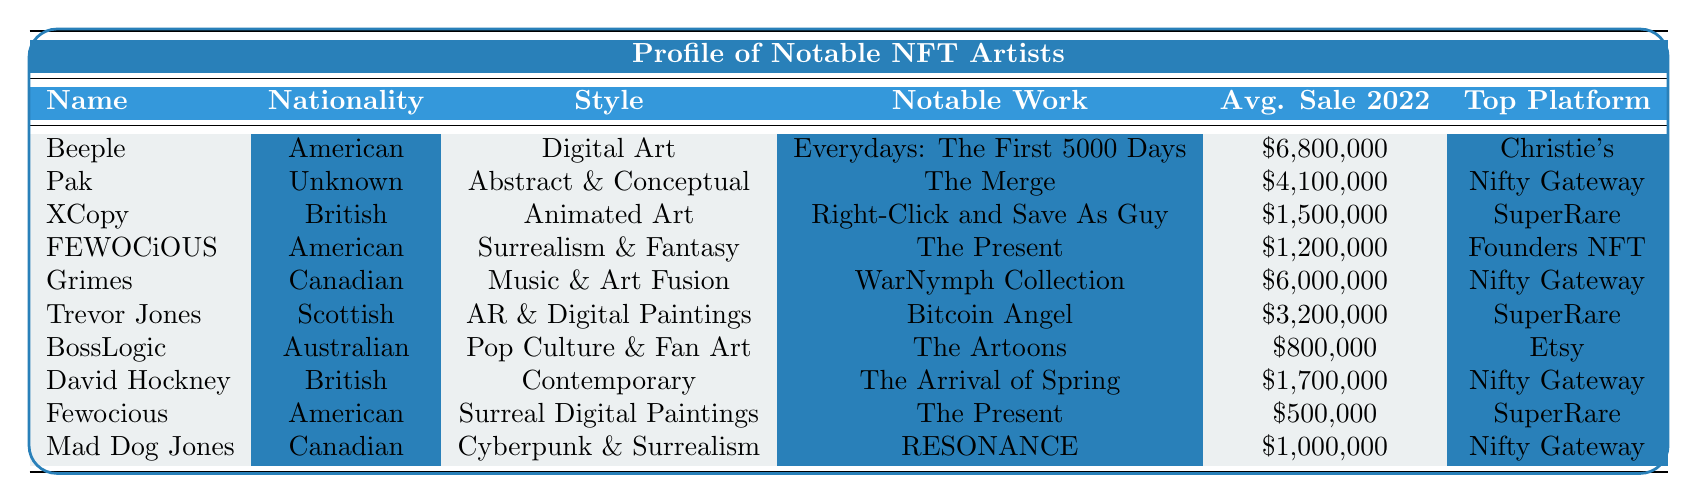What is the nationality of Beeple? The table lists the nationality of each NFT artist. For Beeple, the nationality is explicitly mentioned as "American."
Answer: American Which artist's average sale is the highest in 2022? By comparing the "Average Sale 2022" values in the table, Beeple has the highest figure at $6,800,000.
Answer: Beeple How many artists have an average sale of over $2,000,000 in 2022? Checking the average sale values, the artists with sales over $2,000,000 are Beeple, Pak, Grimes, Trevor Jones, and XCopy. This totals 5 artists.
Answer: 5 Is XCopy of British nationality? The table states that XCopy's nationality is "British." Therefore, the statement is true.
Answer: Yes What is the combined average sale of the three artists with the lowest average sales? The three artists with the lowest averages are BossLogic ($800,000), Fewocious ($500,000), and Mad Dog Jones ($1,000,000). Combining these values, we get $800,000 + $500,000 + $1,000,000 = $2,300,000. The average is $2,300,000 / 3 = $766,667.
Answer: $766,667 Which platform has the most artists listed as their top platform? In the table, we count the occurrences of each top platform. Nifty Gateway appears 4 times (Pak, Grimes, David Hockney, Mad Dog Jones), SuperRare occurs 3 times (XCopy, Trevor Jones, Fewocious), Christie's occurs 1 time, and Etsy occurs 1 time. Therefore, Nifty Gateway has the most.
Answer: Nifty Gateway What style does the artist FEWOCiOUS represent? Referring to the table, FEWOCiOUS is listed under the "Style" column as "Surrealism & Fantasy."
Answer: Surrealism & Fantasy What is the difference between the highest and lowest average sales in 2022? According to the table, the highest average sale is Beeple's $6,800,000 and the lowest is Fewocious's $500,000. The difference is $6,800,000 - $500,000 = $6,300,000.
Answer: $6,300,000 How many artists listed utilize digital art as their style? From the table, digital art styles are represented by Beeple, XCopy, FEWOCiOUS, and Trevor Jones, totaling 4 artists.
Answer: 4 Does the artist Grimes have a notable work titled "WarNymph Collection"? The table confirms that Grimes's notable work is indeed listed as "WarNymph Collection." Thus, the statement is true.
Answer: Yes 